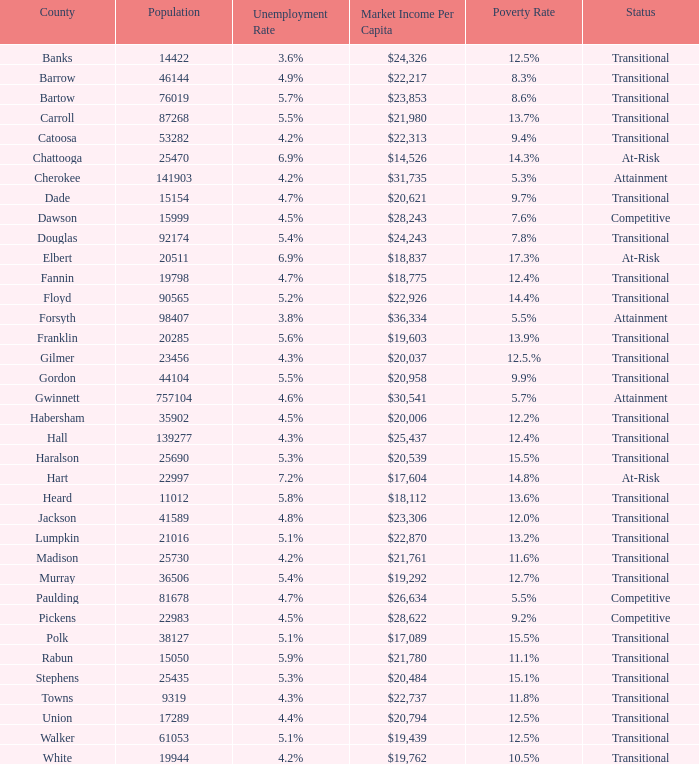Which county had a 3.6% unemployment rate? Banks. 